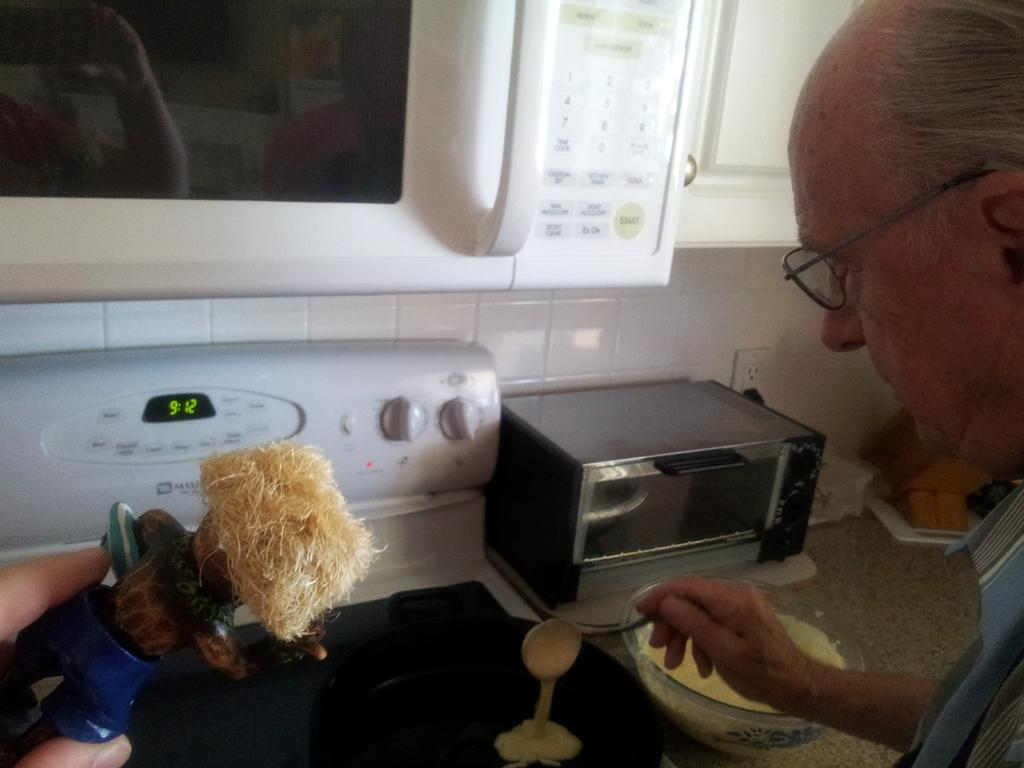Provide a one-sentence caption for the provided image. A man pouring pancake mix on the stove with the clock showing the time of 9:12. 